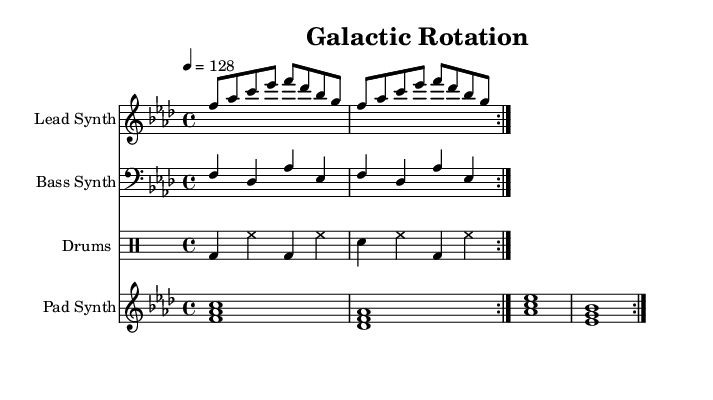What is the key signature of this music? The key signature is indicated at the beginning of the staff. In this case, there are four flats, which corresponds to the key of F minor.
Answer: F minor What is the time signature of this music? The time signature is found just after the key signature. Here, it is indicated as 4/4, meaning there are four beats per measure, with each quarter note getting one beat.
Answer: 4/4 What is the tempo of this piece? The tempo marking is located at the beginning of the score. It indicates a speed of 128 beats per minute, which is represented by the notation "4 = 128".
Answer: 128 How many measures are repeated in the lead synth part? The repeat symbols at the beginning of the lead synth part indicate that the entire section will be played twice.
Answer: 2 What types of synths are used in this music? The score lists four distinct parts: Lead Synth, Bass Synth, Pad Synth, and Drums, which are indicated in the instrument names at the start of each staff.
Answer: Lead Synth, Bass Synth, Pad Synth, Drums Which drum elements are used in the drums part? The drum notation specifies bass drum ('bd'), snare drum ('sn'), and hi-hat ('hh') within the drummode context, which outlines the rhythms for each.
Answer: Bass drum, snare drum, hi-hat What chord does the pad synth play in the second measure? The notation under the pad synth section shows that it plays the chord consisting of the notes D, F, and A flat in the second measure.
Answer: D minor 